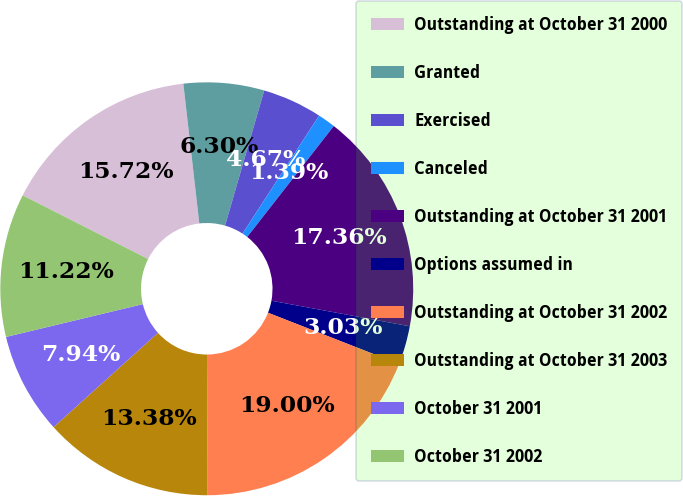Convert chart to OTSL. <chart><loc_0><loc_0><loc_500><loc_500><pie_chart><fcel>Outstanding at October 31 2000<fcel>Granted<fcel>Exercised<fcel>Canceled<fcel>Outstanding at October 31 2001<fcel>Options assumed in<fcel>Outstanding at October 31 2002<fcel>Outstanding at October 31 2003<fcel>October 31 2001<fcel>October 31 2002<nl><fcel>15.72%<fcel>6.3%<fcel>4.67%<fcel>1.39%<fcel>17.36%<fcel>3.03%<fcel>19.0%<fcel>13.38%<fcel>7.94%<fcel>11.22%<nl></chart> 